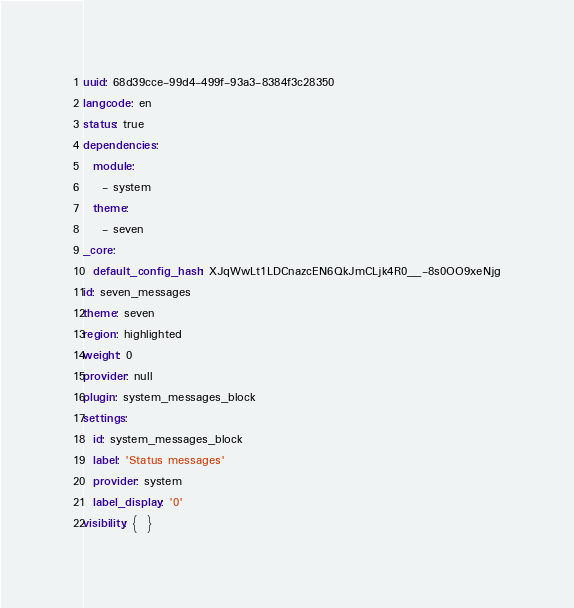<code> <loc_0><loc_0><loc_500><loc_500><_YAML_>uuid: 68d39cce-99d4-499f-93a3-8384f3c28350
langcode: en
status: true
dependencies:
  module:
    - system
  theme:
    - seven
_core:
  default_config_hash: XJqWwLt1LDCnazcEN6QkJmCLjk4R0__-8s0OO9xeNjg
id: seven_messages
theme: seven
region: highlighted
weight: 0
provider: null
plugin: system_messages_block
settings:
  id: system_messages_block
  label: 'Status messages'
  provider: system
  label_display: '0'
visibility: {  }
</code> 